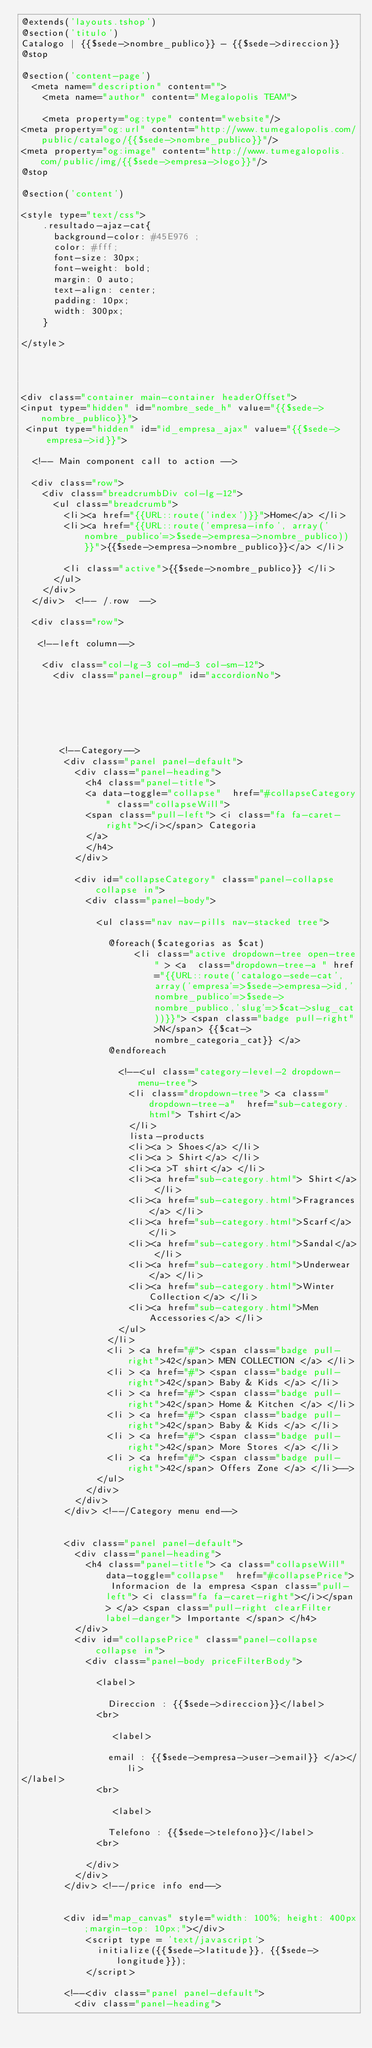Convert code to text. <code><loc_0><loc_0><loc_500><loc_500><_PHP_>@extends('layouts.tshop')
@section('titulo')
Catalogo | {{$sede->nombre_publico}} - {{$sede->direccion}}
@stop

@section('content-page')
  <meta name="description" content="">
    <meta name="author" content="Megalopolis TEAM">

    <meta property="og:type" content="website"/>
<meta property="og:url" content="http://www.tumegalopolis.com/public/catalogo/{{$sede->nombre_publico}}"/>
<meta property="og:image" content="http://www.tumegalopolis.com/public/img/{{$sede->empresa->logo}}"/>
@stop

@section('content')

<style type="text/css">
    .resultado-ajaz-cat{
      background-color: #45E976 ;
      color: #fff;
      font-size: 30px;
      font-weight: bold;
      margin: 0 auto;
      text-align: center;
      padding: 10px;
      width: 300px;
    }

</style>

    


<div class="container main-container headerOffset"> 
<input type="hidden" id="nombre_sede_h" value="{{$sede->nombre_publico}}">
 <input type="hidden" id="id_empresa_ajax" value="{{$sede->empresa->id}}">
  
  <!-- Main component call to action -->
  
  <div class="row">
    <div class="breadcrumbDiv col-lg-12">
      <ul class="breadcrumb">
        <li><a href="{{URL::route('index')}}">Home</a> </li>
        <li><a href="{{URL::route('empresa-info', array('nombre_publico'=>$sede->empresa->nombre_publico))}}">{{$sede->empresa->nombre_publico}}</a> </li>
        
        <li class="active">{{$sede->nombre_publico}} </li>
      </ul>
    </div>
  </div>  <!-- /.row  --> 
  
  <div class="row">
  
   <!--left column-->
  
    <div class="col-lg-3 col-md-3 col-sm-12">
      <div class="panel-group" id="accordionNo">






       <!--Category--> 
        <div class="panel panel-default">
          <div class="panel-heading">
            <h4 class="panel-title"> 
            <a data-toggle="collapse"  href="#collapseCategory" class="collapseWill"> 
            <span class="pull-left"> <i class="fa fa-caret-right"></i></span> Categoria
            </a> 
            </h4>
          </div>
          
          <div id="collapseCategory" class="panel-collapse collapse in">
            <div class="panel-body">

              <ul class="nav nav-pills nav-stacked tree">

                @foreach($categorias as $cat)
                     <li class="active dropdown-tree open-tree" > <a  class="dropdown-tree-a " href="{{URL::route('catalogo-sede-cat', array('empresa'=>$sede->empresa->id,'nombre_publico'=>$sede->nombre_publico,'slug'=>$cat->slug_cat))}}"> <span class="badge pull-right">N</span> {{$cat->nombre_categoria_cat}} </a>
                @endforeach
               
                  <!--<ul class="category-level-2 dropdown-menu-tree">
                    <li class="dropdown-tree"> <a class="dropdown-tree-a"  href="sub-category.html"> Tshirt</a>
                    </li>
                    lista-products
                    <li><a > Shoes</a> </li>
                    <li><a > Shirt</a> </li>
                    <li><a >T shirt</a> </li>
                    <li><a href="sub-category.html"> Shirt</a> </li>
                    <li><a href="sub-category.html">Fragrances</a> </li>
                    <li><a href="sub-category.html">Scarf</a> </li>
                    <li><a href="sub-category.html">Sandal</a> </li>
                    <li><a href="sub-category.html">Underwear</a> </li>
                    <li><a href="sub-category.html">Winter Collection</a> </li>
                    <li><a href="sub-category.html">Men Accessories</a> </li>
                  </ul>
                </li>
                <li > <a href="#"> <span class="badge pull-right">42</span> MEN COLLECTION </a> </li>
                <li > <a href="#"> <span class="badge pull-right">42</span> Baby & Kids </a> </li>
                <li > <a href="#"> <span class="badge pull-right">42</span> Home & Kitchen </a> </li>
                <li > <a href="#"> <span class="badge pull-right">42</span> Baby & Kids </a> </li>
                <li > <a href="#"> <span class="badge pull-right">42</span> More Stores </a> </li>
                <li > <a href="#"> <span class="badge pull-right">42</span> Offers Zone </a> </li>-->
              </ul>
            </div>
          </div>
        </div> <!--/Category menu end--> 


        <div class="panel panel-default">
          <div class="panel-heading">
            <h4 class="panel-title"> <a class="collapseWill" data-toggle="collapse"  href="#collapsePrice"> Informacion de la empresa <span class="pull-left"> <i class="fa fa-caret-right"></i></span> </a> <span class="pull-right clearFilter  label-danger"> Importante </span> </h4>
          </div>
          <div id="collapsePrice" class="panel-collapse collapse in">
            <div class="panel-body priceFilterBody"> 
              
              <label>
                
                Direccion : {{$sede->direccion}}</label>
              <br>

                 <label>
                
                email : {{$sede->empresa->user->email}} </a></li>
</label>
              <br>

                 <label>
                
                Telefono : {{$sede->telefono}}</label>
              <br>
         
            </div>
          </div>
        </div> <!--/price info end--> 


        <div id="map_canvas" style="width: 100%; height: 400px;margin-top: 10px;"></div>
            <script type = 'text/javascript'>
              initialize({{$sede->latitude}}, {{$sede->longitude}});
            </script>
        
        <!--<div class="panel panel-default">
          <div class="panel-heading"></code> 